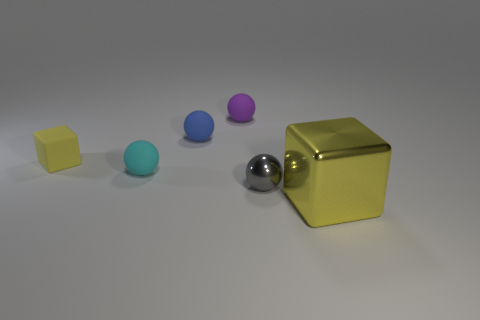What is the material of the block that is the same size as the cyan sphere?
Provide a succinct answer. Rubber. Is the number of small things behind the blue thing the same as the number of blue objects that are behind the matte block?
Make the answer very short. Yes. What number of objects are behind the tiny gray metal object that is in front of the tiny rubber sphere in front of the tiny yellow cube?
Your response must be concise. 4. Do the large object and the tiny matte ball behind the blue ball have the same color?
Provide a succinct answer. No. There is a purple object that is the same material as the blue thing; what is its size?
Ensure brevity in your answer.  Small. Are there more small purple matte balls on the right side of the gray object than brown rubber cylinders?
Provide a succinct answer. No. What material is the block behind the yellow object that is in front of the shiny thing that is on the left side of the large yellow metallic block?
Your answer should be compact. Rubber. Does the gray object have the same material as the cube in front of the tiny cyan object?
Ensure brevity in your answer.  Yes. What material is the blue thing that is the same shape as the tiny purple rubber object?
Your response must be concise. Rubber. Are there more matte objects that are to the right of the cyan matte object than small gray metallic objects in front of the gray metal object?
Ensure brevity in your answer.  Yes. 